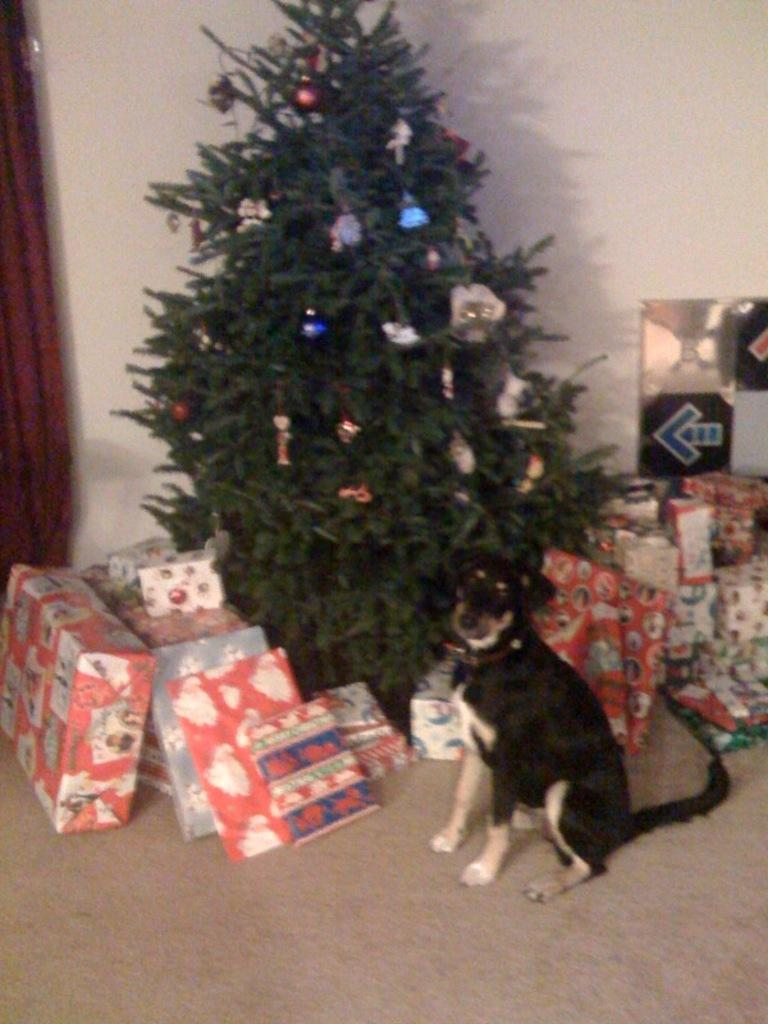What type of animal can be seen in the image? There is a dog in the image. What else is present in the image besides the dog? There are gift boxes and a Christmas tree in the image. What is on the Christmas tree? The Christmas tree has objects on it. What can be seen in the background of the image? There is a wall in the background of the image. What sound does the dog's tongue make in the image? The dog's tongue does not make a sound in the image, as it is not depicted as making any noise. 